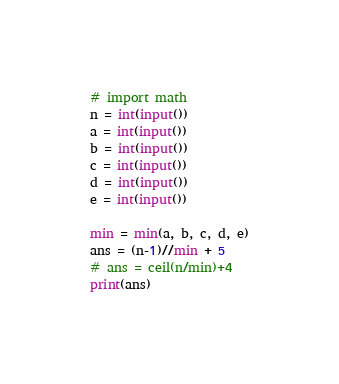<code> <loc_0><loc_0><loc_500><loc_500><_Python_># import math
n = int(input())
a = int(input())
b = int(input())
c = int(input())
d = int(input())
e = int(input())

min = min(a, b, c, d, e)
ans = (n-1)//min + 5
# ans = ceil(n/min)+4
print(ans)
</code> 